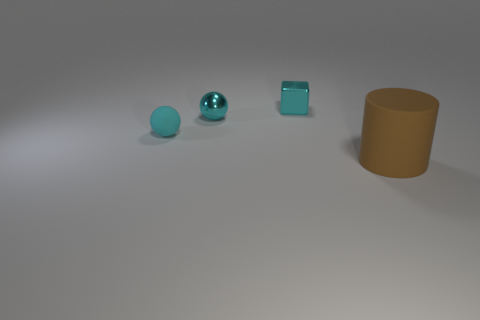Add 3 tiny cyan things. How many objects exist? 7 Add 1 metallic balls. How many metallic balls are left? 2 Add 4 tiny metallic things. How many tiny metallic things exist? 6 Subtract 0 yellow spheres. How many objects are left? 4 Subtract all tiny metal things. Subtract all matte cylinders. How many objects are left? 1 